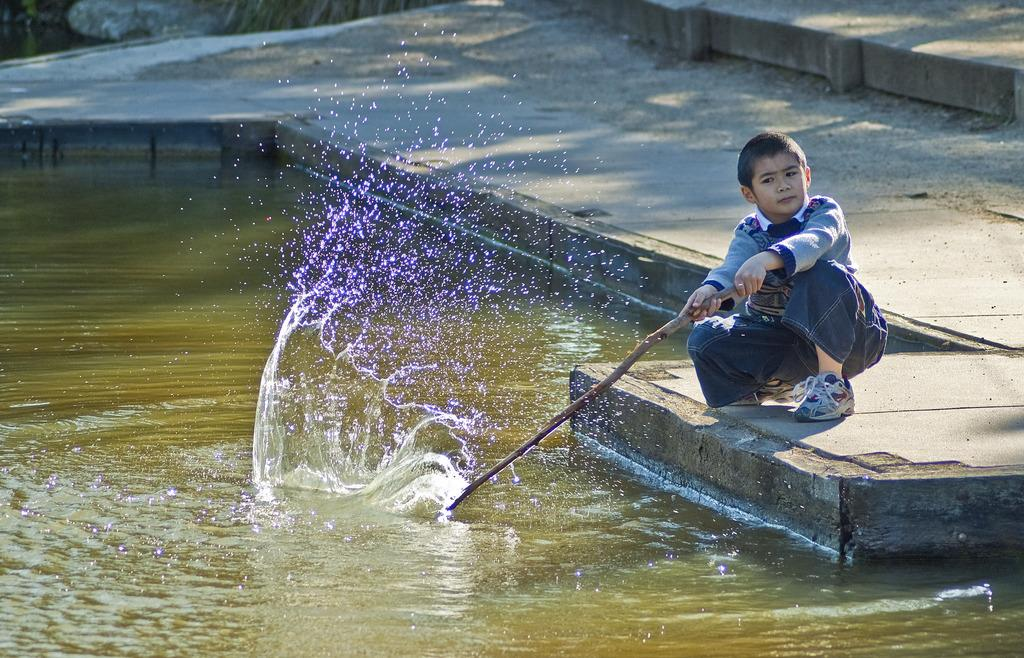What is located on the right side of the image? There is a boy on the right side of the image. What is the boy holding in the image? The boy is holding a stick. What can be seen in front of the boy? There is water visible in front of the boy. What flavor of ice cream is the boy eating in the image? There is no ice cream present in the image; the boy is holding a stick. 